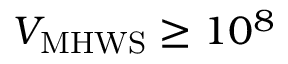<formula> <loc_0><loc_0><loc_500><loc_500>{ V _ { M H W S } } \geq 1 0 ^ { 8 }</formula> 